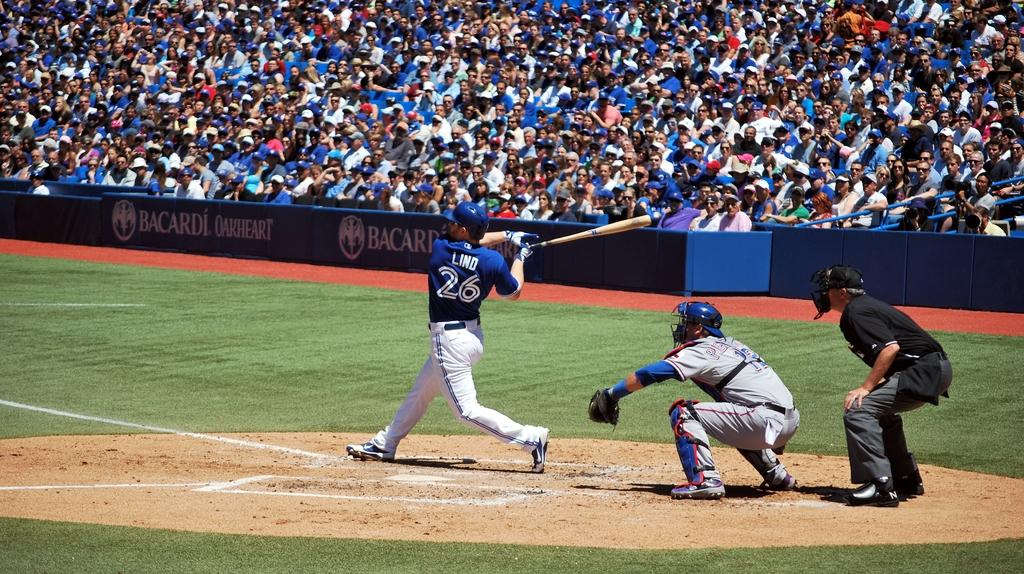<image>
Describe the image concisely. Baseball game stadium with a banner in front of the fans that reads Bacardi Oakheart. 